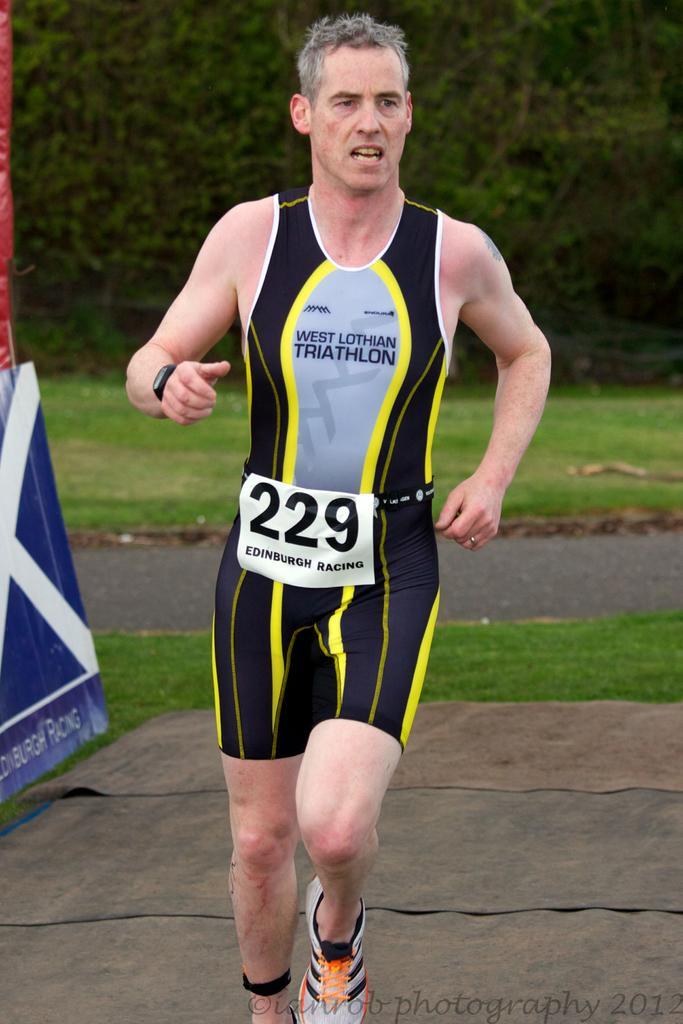How would you summarize this image in a sentence or two? In the middle of the image a man is running. Behind him there is grass and trees. On the left side of the image there is a banner. 